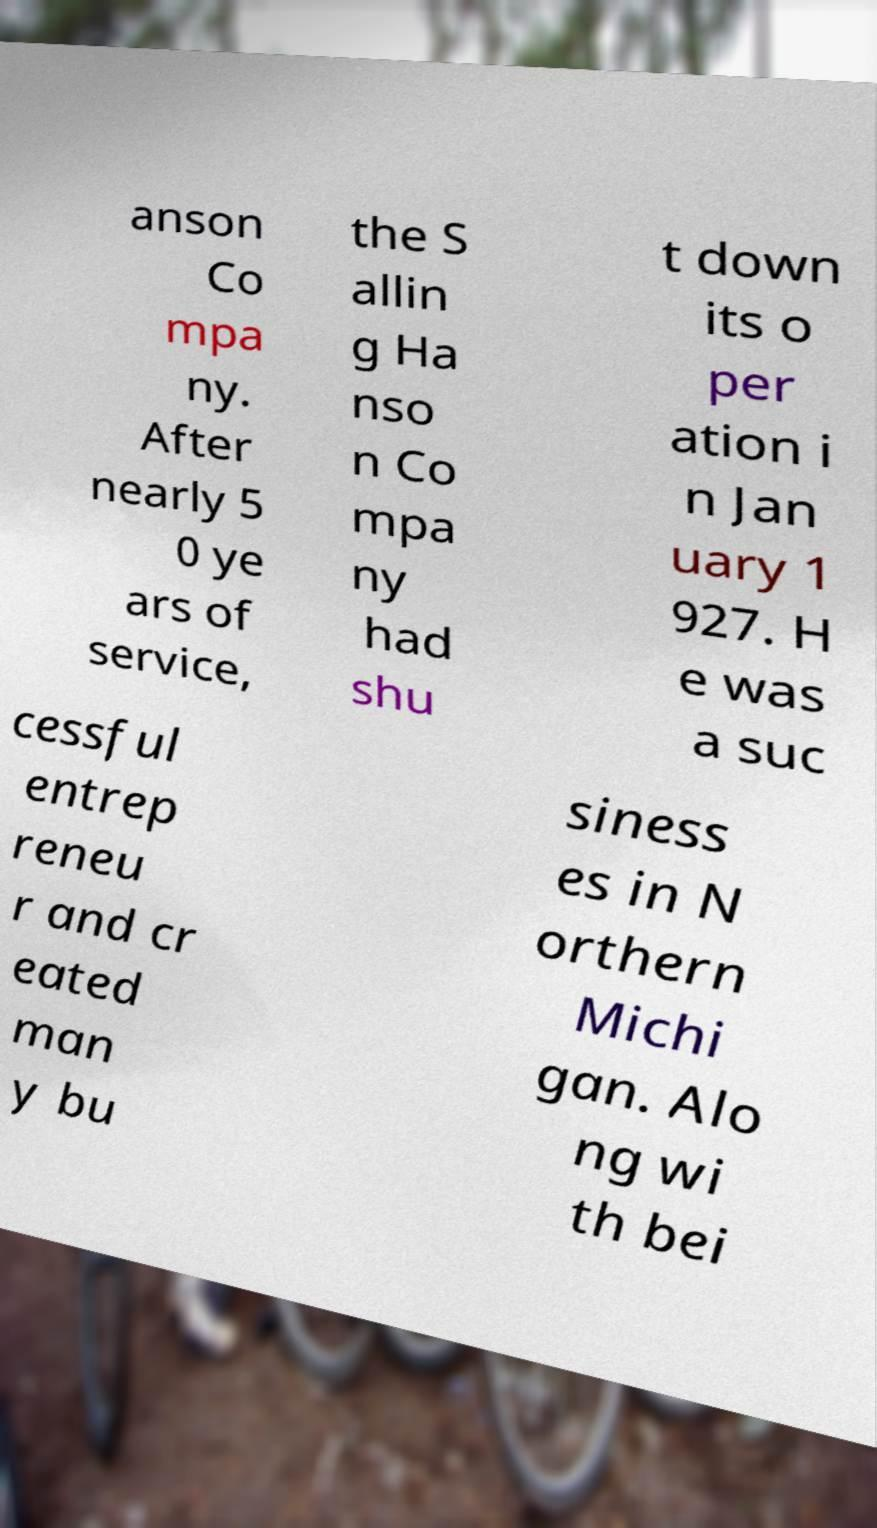Please read and relay the text visible in this image. What does it say? anson Co mpa ny. After nearly 5 0 ye ars of service, the S allin g Ha nso n Co mpa ny had shu t down its o per ation i n Jan uary 1 927. H e was a suc cessful entrep reneu r and cr eated man y bu siness es in N orthern Michi gan. Alo ng wi th bei 